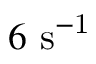<formula> <loc_0><loc_0><loc_500><loc_500>6 { s } ^ { - 1 }</formula> 